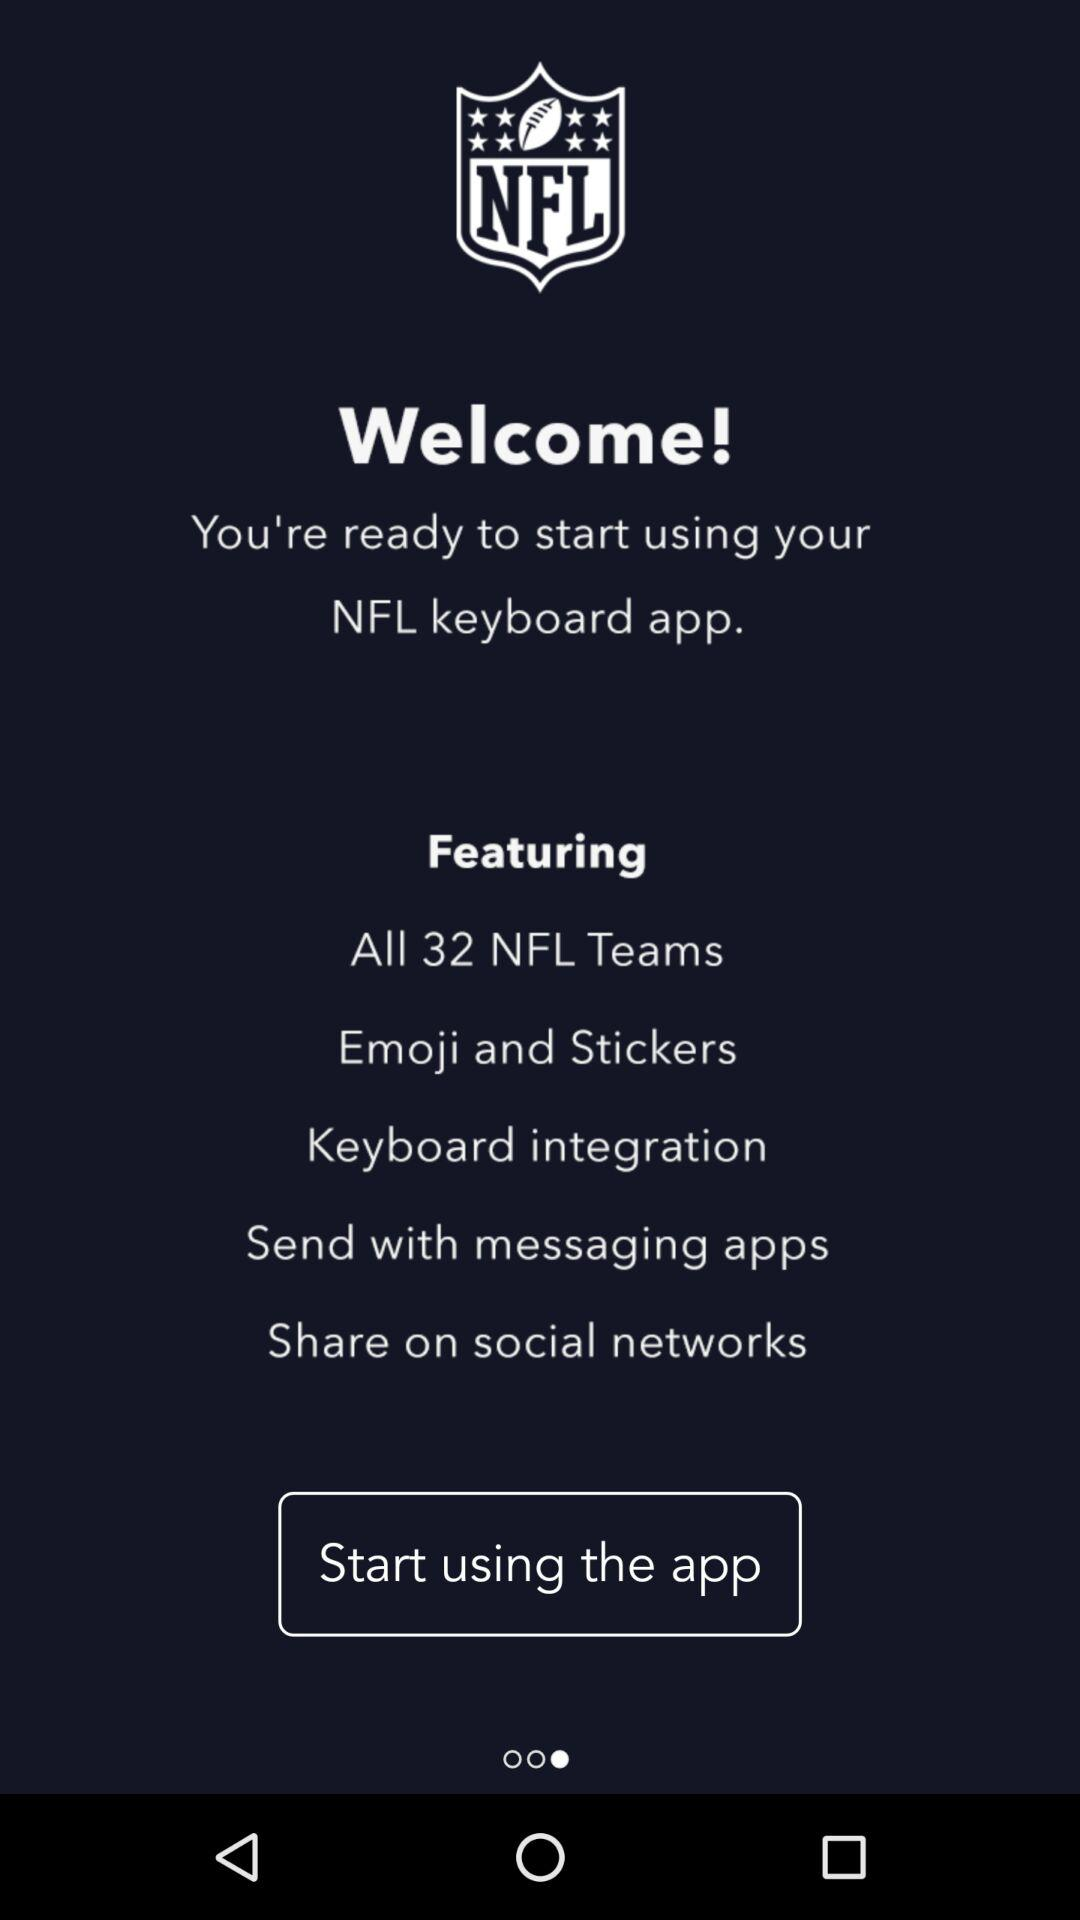What is the feature of the "NFL keyboard" application? The features of the "NFL keyboard" application are "All 32 NFL Teams", "Emoji and Stickers", "Keyboard integration", "Send with messaging apps" and "Share on social networks". 